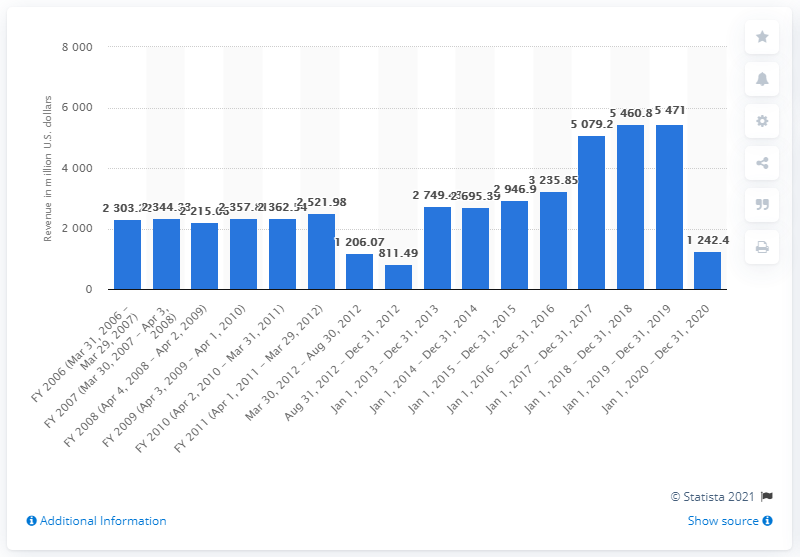Draw attention to some important aspects in this diagram. In 2012, AMC Theatres' revenues were 811.49 million dollars. In the 2020 fiscal year, the annual revenue of AMC Theatres was approximately 1242.4 million dollars. 